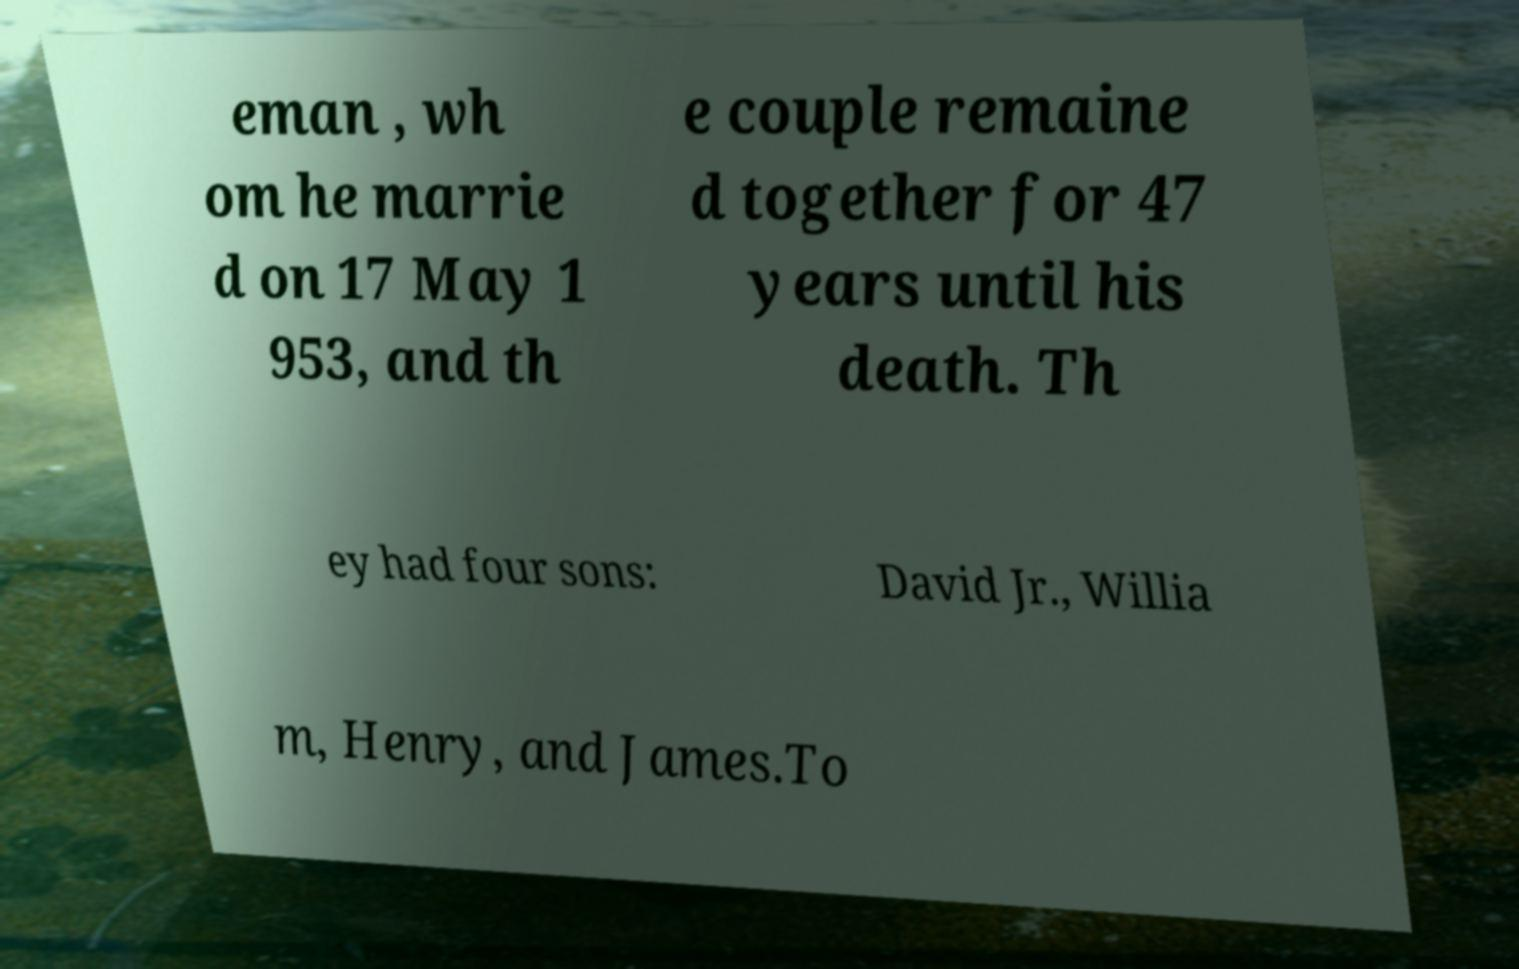There's text embedded in this image that I need extracted. Can you transcribe it verbatim? eman , wh om he marrie d on 17 May 1 953, and th e couple remaine d together for 47 years until his death. Th ey had four sons: David Jr., Willia m, Henry, and James.To 